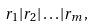Convert formula to latex. <formula><loc_0><loc_0><loc_500><loc_500>r _ { 1 } | r _ { 2 } | \dots | r _ { m } ,</formula> 